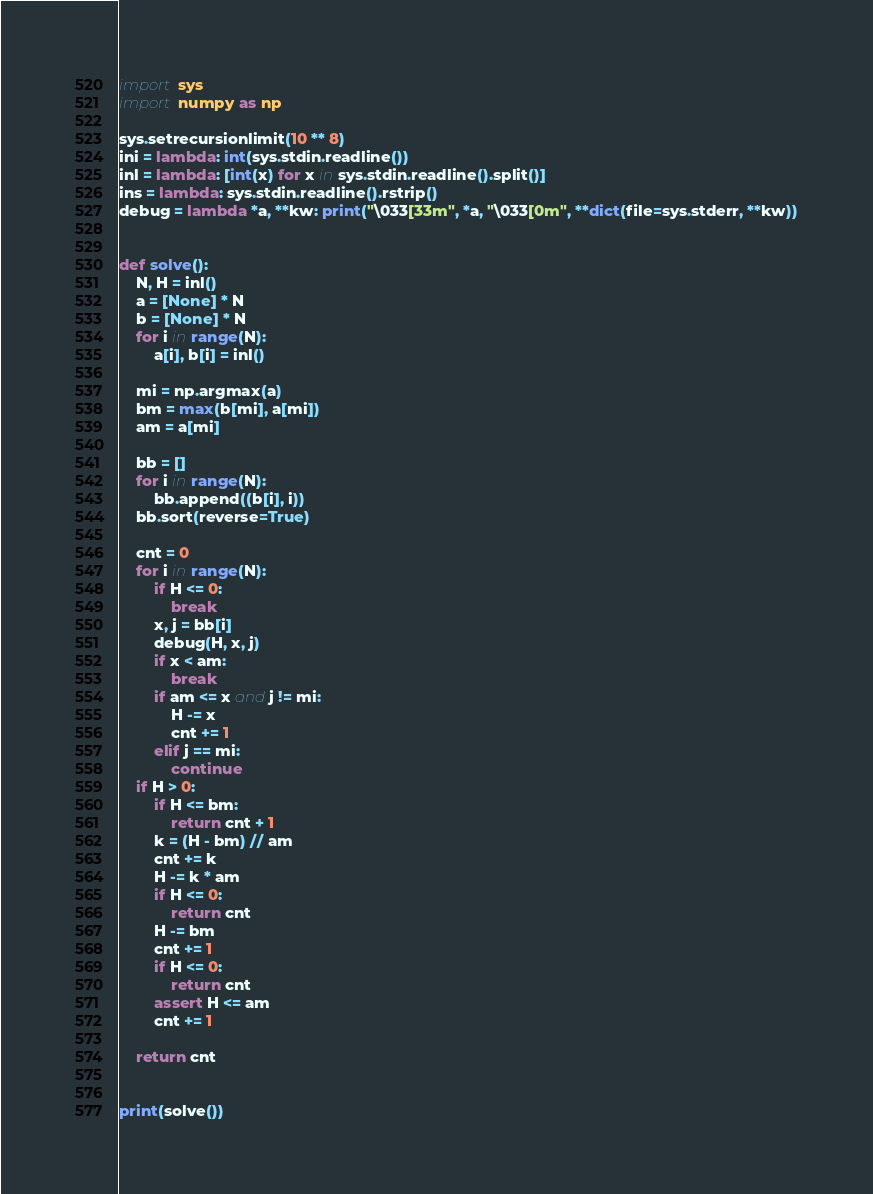<code> <loc_0><loc_0><loc_500><loc_500><_Python_>import sys
import numpy as np

sys.setrecursionlimit(10 ** 8)
ini = lambda: int(sys.stdin.readline())
inl = lambda: [int(x) for x in sys.stdin.readline().split()]
ins = lambda: sys.stdin.readline().rstrip()
debug = lambda *a, **kw: print("\033[33m", *a, "\033[0m", **dict(file=sys.stderr, **kw))


def solve():
    N, H = inl()
    a = [None] * N
    b = [None] * N
    for i in range(N):
        a[i], b[i] = inl()

    mi = np.argmax(a)
    bm = max(b[mi], a[mi])
    am = a[mi]

    bb = []
    for i in range(N):
        bb.append((b[i], i))
    bb.sort(reverse=True)

    cnt = 0
    for i in range(N):
        if H <= 0:
            break
        x, j = bb[i]
        debug(H, x, j)
        if x < am:
            break
        if am <= x and j != mi:
            H -= x
            cnt += 1
        elif j == mi:
            continue
    if H > 0:
        if H <= bm:
            return cnt + 1
        k = (H - bm) // am
        cnt += k
        H -= k * am
        if H <= 0:
            return cnt
        H -= bm
        cnt += 1
        if H <= 0:
            return cnt
        assert H <= am
        cnt += 1

    return cnt


print(solve())
</code> 